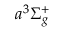Convert formula to latex. <formula><loc_0><loc_0><loc_500><loc_500>a ^ { 3 } \Sigma _ { g } ^ { + }</formula> 